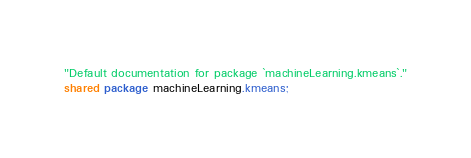Convert code to text. <code><loc_0><loc_0><loc_500><loc_500><_Ceylon_>"Default documentation for package `machineLearning.kmeans`."
shared package machineLearning.kmeans;
</code> 